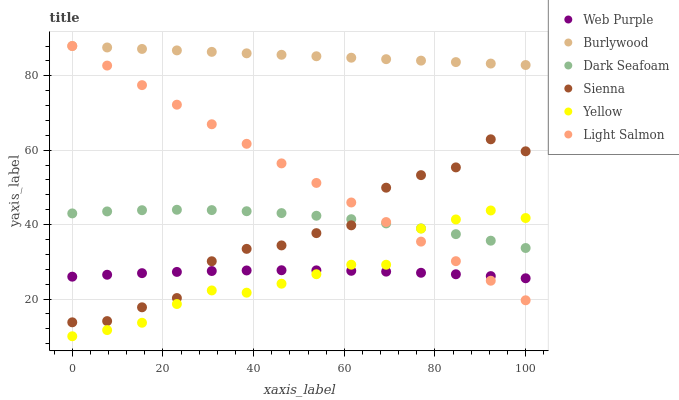Does Yellow have the minimum area under the curve?
Answer yes or no. Yes. Does Burlywood have the maximum area under the curve?
Answer yes or no. Yes. Does Dark Seafoam have the minimum area under the curve?
Answer yes or no. No. Does Dark Seafoam have the maximum area under the curve?
Answer yes or no. No. Is Light Salmon the smoothest?
Answer yes or no. Yes. Is Sienna the roughest?
Answer yes or no. Yes. Is Burlywood the smoothest?
Answer yes or no. No. Is Burlywood the roughest?
Answer yes or no. No. Does Yellow have the lowest value?
Answer yes or no. Yes. Does Dark Seafoam have the lowest value?
Answer yes or no. No. Does Burlywood have the highest value?
Answer yes or no. Yes. Does Dark Seafoam have the highest value?
Answer yes or no. No. Is Web Purple less than Burlywood?
Answer yes or no. Yes. Is Burlywood greater than Yellow?
Answer yes or no. Yes. Does Dark Seafoam intersect Light Salmon?
Answer yes or no. Yes. Is Dark Seafoam less than Light Salmon?
Answer yes or no. No. Is Dark Seafoam greater than Light Salmon?
Answer yes or no. No. Does Web Purple intersect Burlywood?
Answer yes or no. No. 